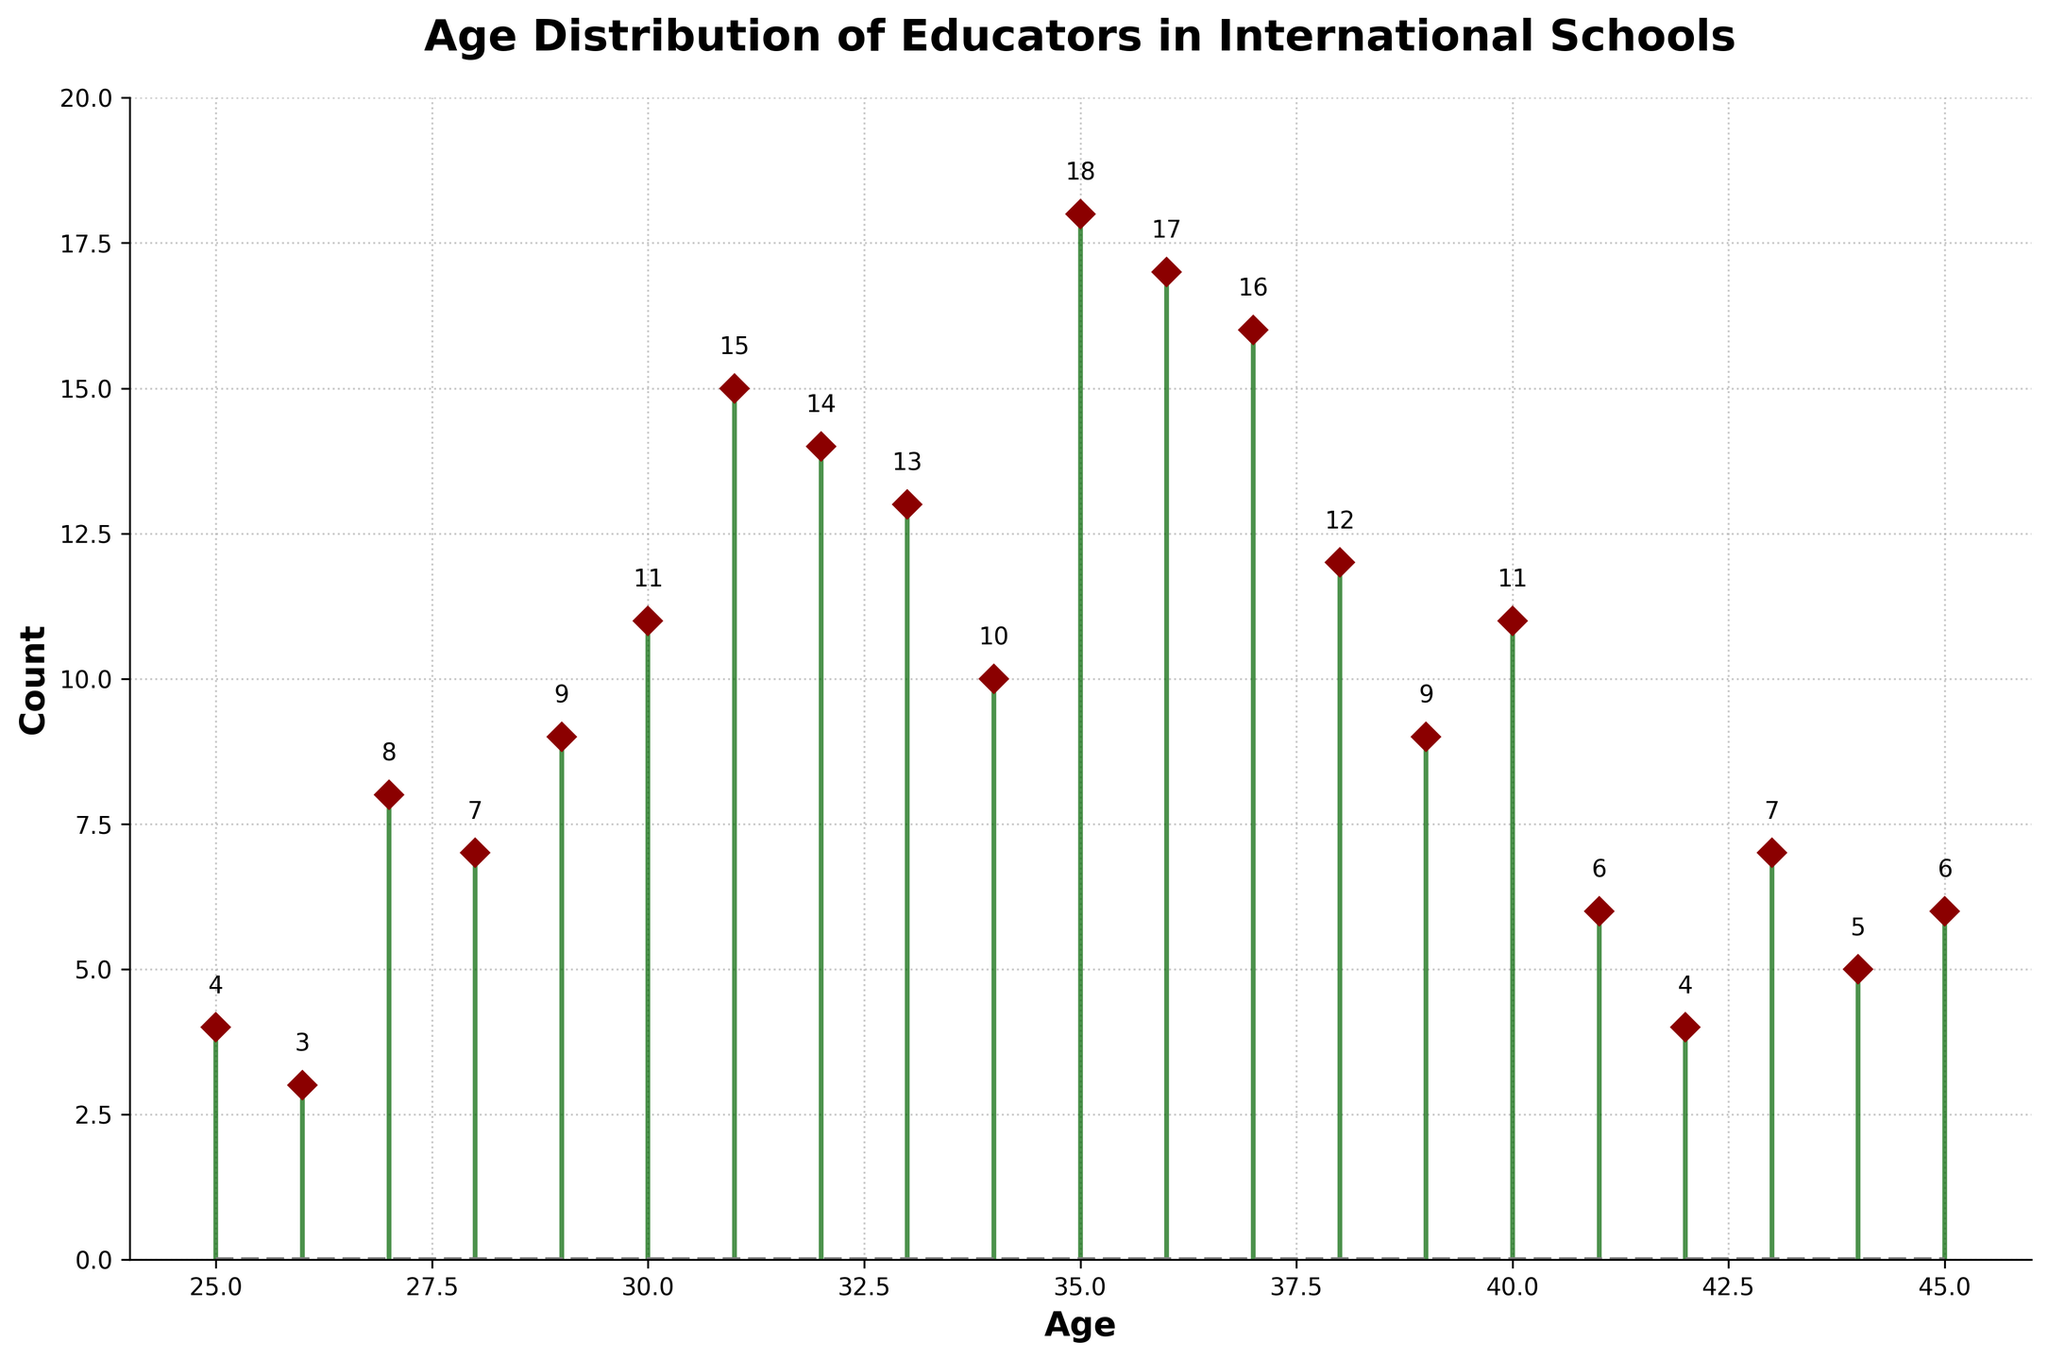What age group has the highest count of educators? By looking at the height of the stems, the age 35 has the peak count. The value next to this stem confirms it as 18.
Answer: 35 How many educators are aged 30? Locate the stem corresponding to age 30. The figure next to the stem is the count, which is 11.
Answer: 11 What's the average number of educators in their 30s (from age 30 to 39)? Sum the counts from age 30 to 39: 11 + 15 + 14 + 13 + 10 + 18 + 17 + 16 + 12 + 9 = 135. There are 10 values, so the average is 135 / 10 = 13.5
Answer: 13.5 Compare the count of educators at age 26 and age 42. Which age has more educators? Locate the stems for ages 26 and 42. The counts are 3 and 4 respectively. Since 4 is greater than 3, age 42 has more educators.
Answer: Age 42 Which age group has the smallest count of educators? Identify the shortest stem. The shortest stem corresponds to age 26, with a count of 3.
Answer: Age 26 What is the median count for educators aged between 25 and 45? List the counts: [4, 3, 8, 7, 9, 11, 15, 14, 13, 10, 18, 17, 16, 12, 9, 11, 6, 4, 7, 5, 6]. Sort resulting list: [3, 4, 4, 5, 6, 6, 7, 7, 8, 9, 9, 10, 11, 11, 12, 13, 14, 15, 16, 17, 18]. The median count is the middle value in this 21-item list, which is 10.
Answer: 10 How does the count of educators change from age 35 to age 36? Locate ages 35 and 36. The counts are 18 and 17 respectively. The count decreases by 1 (18 - 17).
Answer: Decreases by 1 What's the sum of educators aged between 40 and 45? Sum the counts for ages 40 to 45: 11 + 6 + 4 + 7 + 5 + 6 = 39
Answer: 39 Are there more educators in their 20s (ages 25-29) or their 40s (ages 40-45)? Sum the counts for ages 25-29 and 40-45. For the 20s: 4 + 3 + 8 + 7 + 9 = 31. For the 40s: 11 + 6 + 4 + 7 + 5 + 6 = 39. Since 39 is greater than 31, there are more educators in their 40s.
Answer: 40s Is the distribution of educators' ages symmetrical around the mean age? The mean age range was calculated as mid-30s to mid-40s skewed slightly to the left (younger). The counts are higher in the middle, dropping towards the higher and lower edges. Thus, it is roughly symmetrical but skewed towards younger ages.
Answer: No 